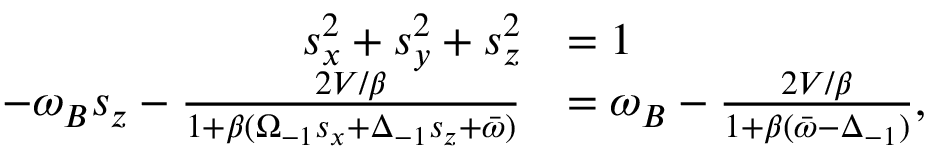<formula> <loc_0><loc_0><loc_500><loc_500>\begin{array} { r l } { s _ { x } ^ { 2 } + s _ { y } ^ { 2 } + s _ { z } ^ { 2 } } & { = 1 } \\ { - \omega _ { B } s _ { z } - \frac { 2 V / \beta } { 1 + \beta ( \Omega _ { - 1 } s _ { x } + \Delta _ { - 1 } s _ { z } + \bar { \omega } ) } } & { = \omega _ { B } - \frac { 2 V / \beta } { 1 + \beta ( \bar { \omega } - \Delta _ { - 1 } ) } , } \end{array}</formula> 